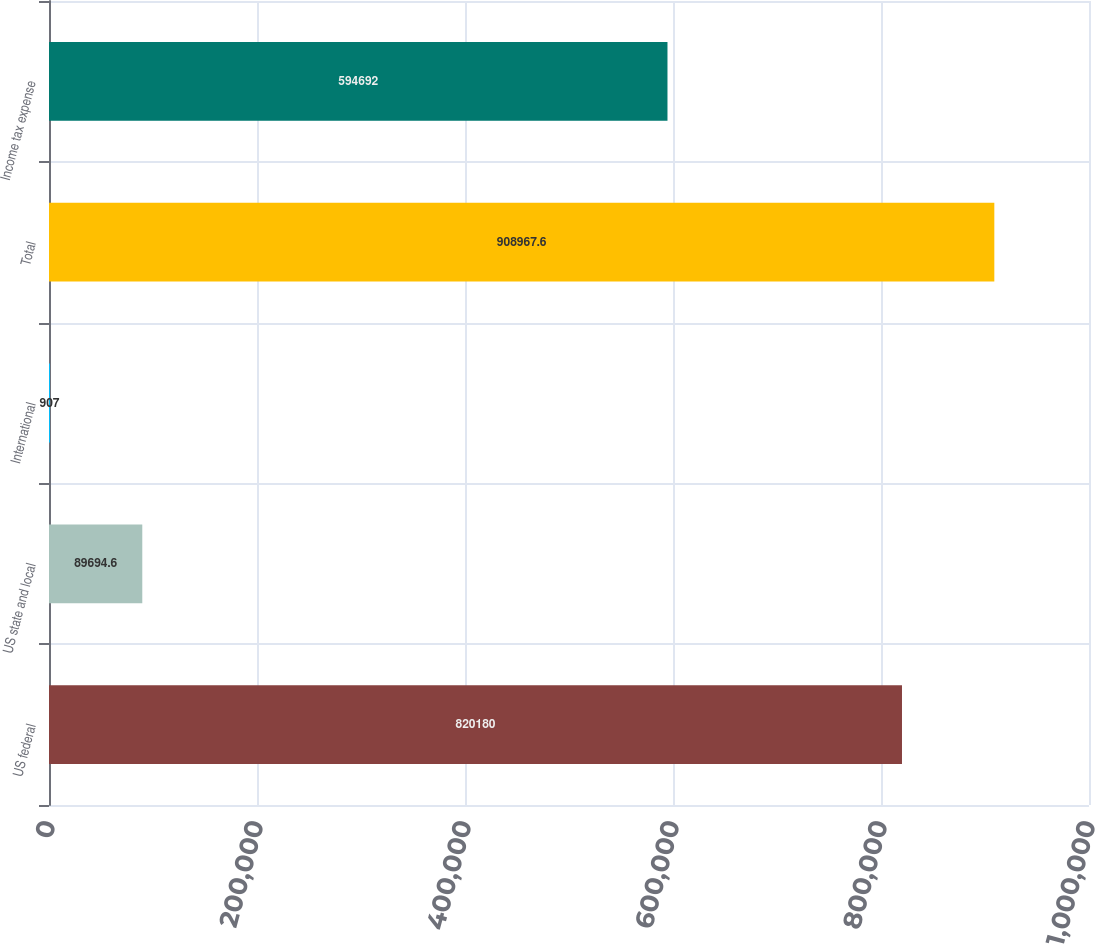<chart> <loc_0><loc_0><loc_500><loc_500><bar_chart><fcel>US federal<fcel>US state and local<fcel>International<fcel>Total<fcel>Income tax expense<nl><fcel>820180<fcel>89694.6<fcel>907<fcel>908968<fcel>594692<nl></chart> 